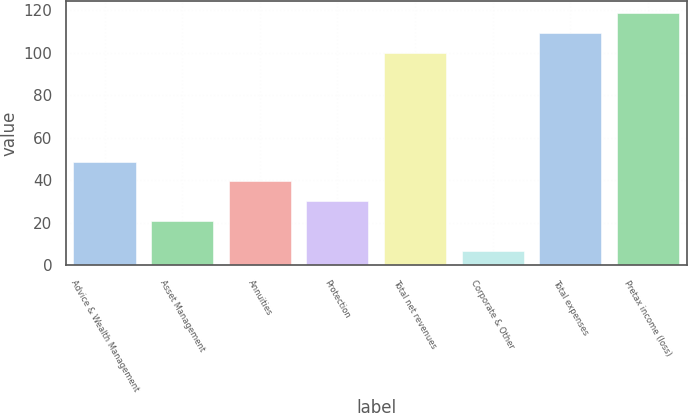Convert chart to OTSL. <chart><loc_0><loc_0><loc_500><loc_500><bar_chart><fcel>Advice & Wealth Management<fcel>Asset Management<fcel>Annuities<fcel>Protection<fcel>Total net revenues<fcel>Corporate & Other<fcel>Total expenses<fcel>Pretax income (loss)<nl><fcel>48.9<fcel>21<fcel>39.6<fcel>30.3<fcel>100<fcel>7<fcel>109.3<fcel>118.6<nl></chart> 